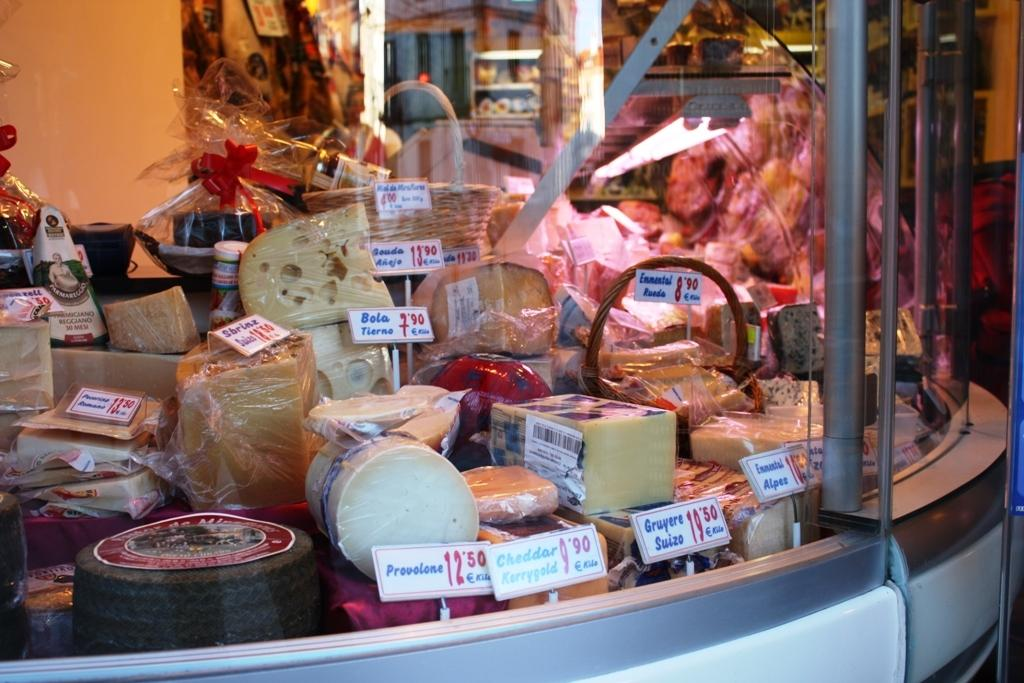What types of food can be seen in the image? There are different types of cheese in the image. How are the cheese displayed in the image? The cheese is placed behind a glass window. Are there any additional details about the cheese in the image? Yes, there are price tags attached to the cheese. How does the stomach feel about the competition in the image? There is no stomach or competition present in the image; it features different types of cheese behind a glass window with price tags attached. 